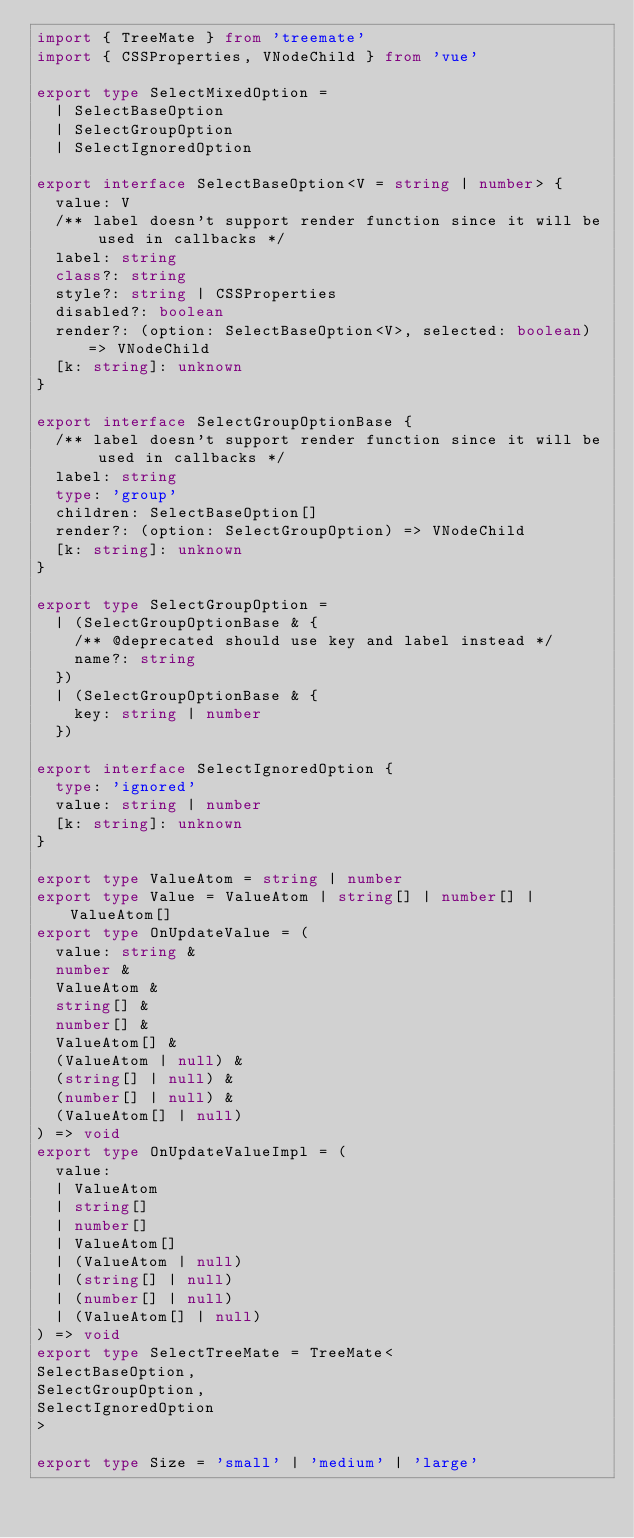<code> <loc_0><loc_0><loc_500><loc_500><_TypeScript_>import { TreeMate } from 'treemate'
import { CSSProperties, VNodeChild } from 'vue'

export type SelectMixedOption =
  | SelectBaseOption
  | SelectGroupOption
  | SelectIgnoredOption

export interface SelectBaseOption<V = string | number> {
  value: V
  /** label doesn't support render function since it will be used in callbacks */
  label: string
  class?: string
  style?: string | CSSProperties
  disabled?: boolean
  render?: (option: SelectBaseOption<V>, selected: boolean) => VNodeChild
  [k: string]: unknown
}

export interface SelectGroupOptionBase {
  /** label doesn't support render function since it will be used in callbacks */
  label: string
  type: 'group'
  children: SelectBaseOption[]
  render?: (option: SelectGroupOption) => VNodeChild
  [k: string]: unknown
}

export type SelectGroupOption =
  | (SelectGroupOptionBase & {
    /** @deprecated should use key and label instead */
    name?: string
  })
  | (SelectGroupOptionBase & {
    key: string | number
  })

export interface SelectIgnoredOption {
  type: 'ignored'
  value: string | number
  [k: string]: unknown
}

export type ValueAtom = string | number
export type Value = ValueAtom | string[] | number[] | ValueAtom[]
export type OnUpdateValue = (
  value: string &
  number &
  ValueAtom &
  string[] &
  number[] &
  ValueAtom[] &
  (ValueAtom | null) &
  (string[] | null) &
  (number[] | null) &
  (ValueAtom[] | null)
) => void
export type OnUpdateValueImpl = (
  value:
  | ValueAtom
  | string[]
  | number[]
  | ValueAtom[]
  | (ValueAtom | null)
  | (string[] | null)
  | (number[] | null)
  | (ValueAtom[] | null)
) => void
export type SelectTreeMate = TreeMate<
SelectBaseOption,
SelectGroupOption,
SelectIgnoredOption
>

export type Size = 'small' | 'medium' | 'large'
</code> 